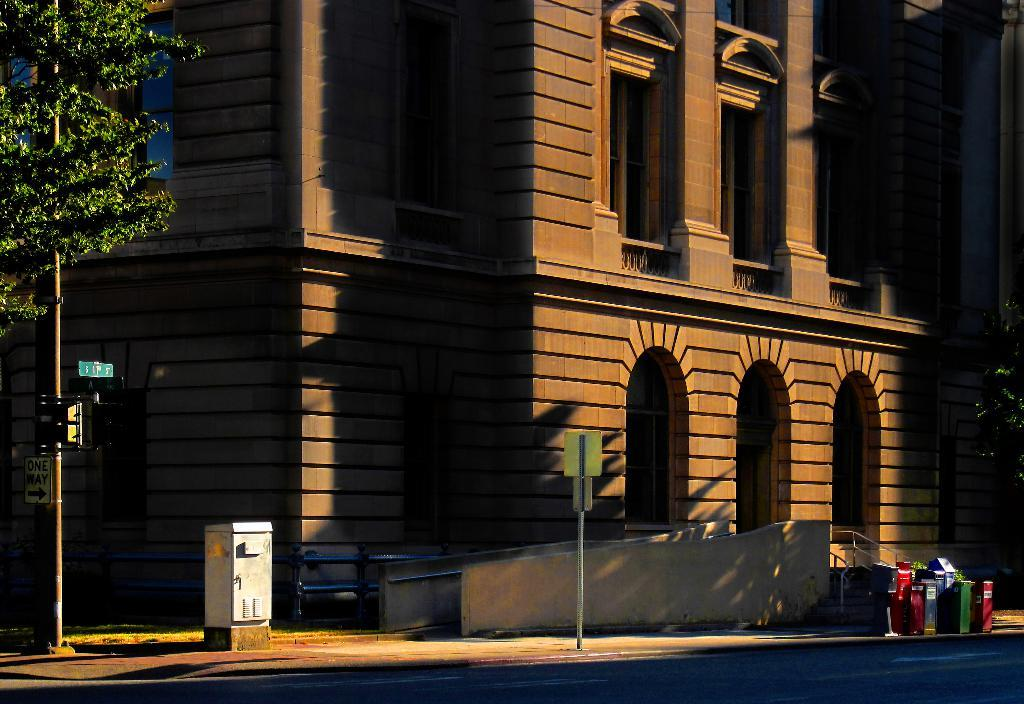What structures can be seen in the image? There are poles, boxes on the road, and a building in the image. What architectural features are present in the image? There are windows in the image. What type of natural elements can be seen in the image? There are trees in the image. What part of the natural environment is visible in the image? The sky is visible in the image. Can you describe the lighting conditions in the image? The image may have been taken during the night, as there is no indication of daylight. What type of behavior can be observed in the image? There is no behavior depicted in the image, as it features inanimate objects such as poles, boxes, and a building. What type of badge is visible on the building in the image? There is no badge present on the building in the image. 